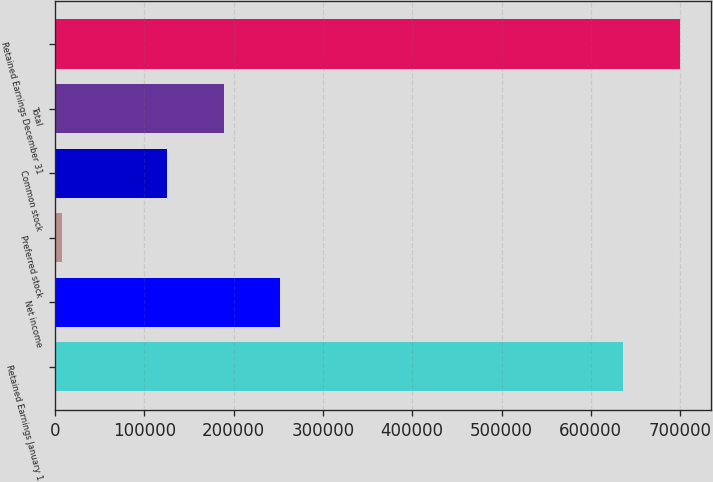Convert chart. <chart><loc_0><loc_0><loc_500><loc_500><bar_chart><fcel>Retained Earnings January 1<fcel>Net income<fcel>Preferred stock<fcel>Common stock<fcel>Total<fcel>Retained Earnings December 31<nl><fcel>636226<fcel>251983<fcel>7776<fcel>125900<fcel>188942<fcel>699268<nl></chart> 